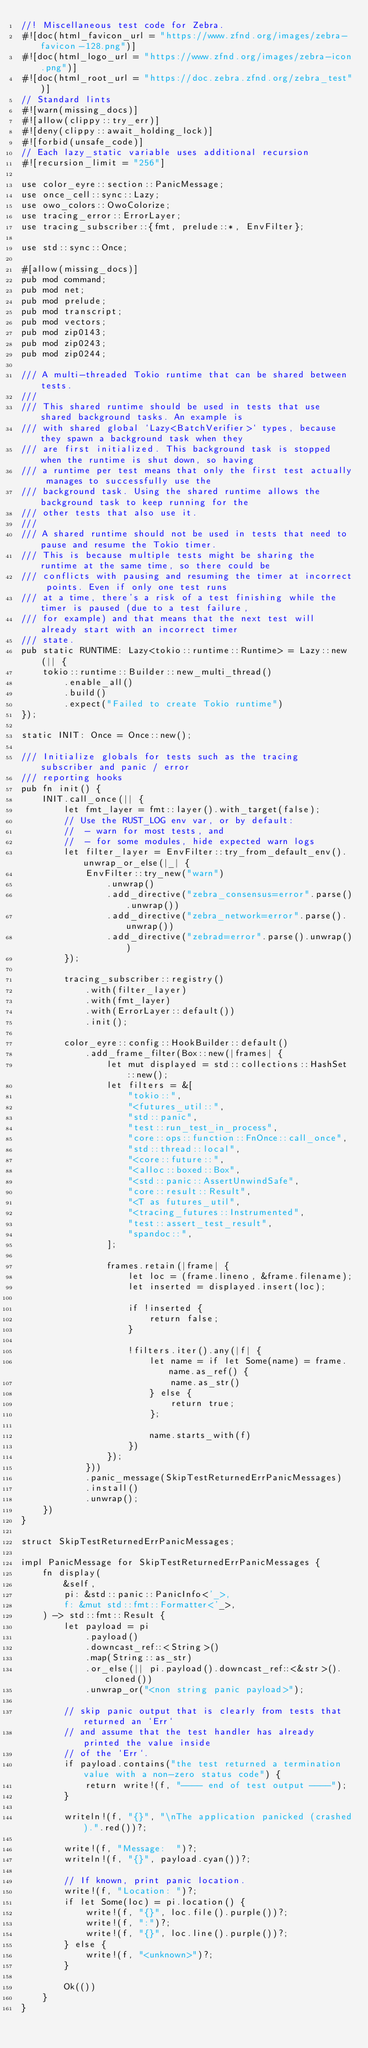Convert code to text. <code><loc_0><loc_0><loc_500><loc_500><_Rust_>//! Miscellaneous test code for Zebra.
#![doc(html_favicon_url = "https://www.zfnd.org/images/zebra-favicon-128.png")]
#![doc(html_logo_url = "https://www.zfnd.org/images/zebra-icon.png")]
#![doc(html_root_url = "https://doc.zebra.zfnd.org/zebra_test")]
// Standard lints
#![warn(missing_docs)]
#![allow(clippy::try_err)]
#![deny(clippy::await_holding_lock)]
#![forbid(unsafe_code)]
// Each lazy_static variable uses additional recursion
#![recursion_limit = "256"]

use color_eyre::section::PanicMessage;
use once_cell::sync::Lazy;
use owo_colors::OwoColorize;
use tracing_error::ErrorLayer;
use tracing_subscriber::{fmt, prelude::*, EnvFilter};

use std::sync::Once;

#[allow(missing_docs)]
pub mod command;
pub mod net;
pub mod prelude;
pub mod transcript;
pub mod vectors;
pub mod zip0143;
pub mod zip0243;
pub mod zip0244;

/// A multi-threaded Tokio runtime that can be shared between tests.
///
/// This shared runtime should be used in tests that use shared background tasks. An example is
/// with shared global `Lazy<BatchVerifier>` types, because they spawn a background task when they
/// are first initialized. This background task is stopped when the runtime is shut down, so having
/// a runtime per test means that only the first test actually manages to successfully use the
/// background task. Using the shared runtime allows the background task to keep running for the
/// other tests that also use it.
///
/// A shared runtime should not be used in tests that need to pause and resume the Tokio timer.
/// This is because multiple tests might be sharing the runtime at the same time, so there could be
/// conflicts with pausing and resuming the timer at incorrect points. Even if only one test runs
/// at a time, there's a risk of a test finishing while the timer is paused (due to a test failure,
/// for example) and that means that the next test will already start with an incorrect timer
/// state.
pub static RUNTIME: Lazy<tokio::runtime::Runtime> = Lazy::new(|| {
    tokio::runtime::Builder::new_multi_thread()
        .enable_all()
        .build()
        .expect("Failed to create Tokio runtime")
});

static INIT: Once = Once::new();

/// Initialize globals for tests such as the tracing subscriber and panic / error
/// reporting hooks
pub fn init() {
    INIT.call_once(|| {
        let fmt_layer = fmt::layer().with_target(false);
        // Use the RUST_LOG env var, or by default:
        //  - warn for most tests, and
        //  - for some modules, hide expected warn logs
        let filter_layer = EnvFilter::try_from_default_env().unwrap_or_else(|_| {
            EnvFilter::try_new("warn")
                .unwrap()
                .add_directive("zebra_consensus=error".parse().unwrap())
                .add_directive("zebra_network=error".parse().unwrap())
                .add_directive("zebrad=error".parse().unwrap())
        });

        tracing_subscriber::registry()
            .with(filter_layer)
            .with(fmt_layer)
            .with(ErrorLayer::default())
            .init();

        color_eyre::config::HookBuilder::default()
            .add_frame_filter(Box::new(|frames| {
                let mut displayed = std::collections::HashSet::new();
                let filters = &[
                    "tokio::",
                    "<futures_util::",
                    "std::panic",
                    "test::run_test_in_process",
                    "core::ops::function::FnOnce::call_once",
                    "std::thread::local",
                    "<core::future::",
                    "<alloc::boxed::Box",
                    "<std::panic::AssertUnwindSafe",
                    "core::result::Result",
                    "<T as futures_util",
                    "<tracing_futures::Instrumented",
                    "test::assert_test_result",
                    "spandoc::",
                ];

                frames.retain(|frame| {
                    let loc = (frame.lineno, &frame.filename);
                    let inserted = displayed.insert(loc);

                    if !inserted {
                        return false;
                    }

                    !filters.iter().any(|f| {
                        let name = if let Some(name) = frame.name.as_ref() {
                            name.as_str()
                        } else {
                            return true;
                        };

                        name.starts_with(f)
                    })
                });
            }))
            .panic_message(SkipTestReturnedErrPanicMessages)
            .install()
            .unwrap();
    })
}

struct SkipTestReturnedErrPanicMessages;

impl PanicMessage for SkipTestReturnedErrPanicMessages {
    fn display(
        &self,
        pi: &std::panic::PanicInfo<'_>,
        f: &mut std::fmt::Formatter<'_>,
    ) -> std::fmt::Result {
        let payload = pi
            .payload()
            .downcast_ref::<String>()
            .map(String::as_str)
            .or_else(|| pi.payload().downcast_ref::<&str>().cloned())
            .unwrap_or("<non string panic payload>");

        // skip panic output that is clearly from tests that returned an `Err`
        // and assume that the test handler has already printed the value inside
        // of the `Err`.
        if payload.contains("the test returned a termination value with a non-zero status code") {
            return write!(f, "---- end of test output ----");
        }

        writeln!(f, "{}", "\nThe application panicked (crashed).".red())?;

        write!(f, "Message:  ")?;
        writeln!(f, "{}", payload.cyan())?;

        // If known, print panic location.
        write!(f, "Location: ")?;
        if let Some(loc) = pi.location() {
            write!(f, "{}", loc.file().purple())?;
            write!(f, ":")?;
            write!(f, "{}", loc.line().purple())?;
        } else {
            write!(f, "<unknown>")?;
        }

        Ok(())
    }
}
</code> 